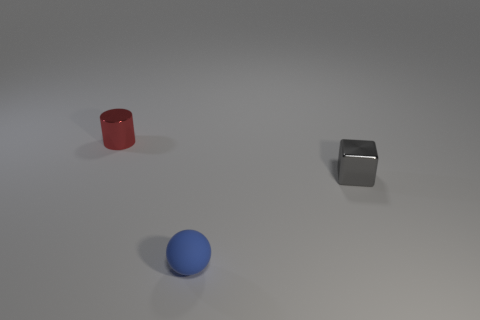Add 1 small blue rubber objects. How many objects exist? 4 Subtract all cylinders. How many objects are left? 2 Subtract all tiny balls. Subtract all small red metal cylinders. How many objects are left? 1 Add 3 small metallic cubes. How many small metallic cubes are left? 4 Add 3 blue spheres. How many blue spheres exist? 4 Subtract 0 purple cylinders. How many objects are left? 3 